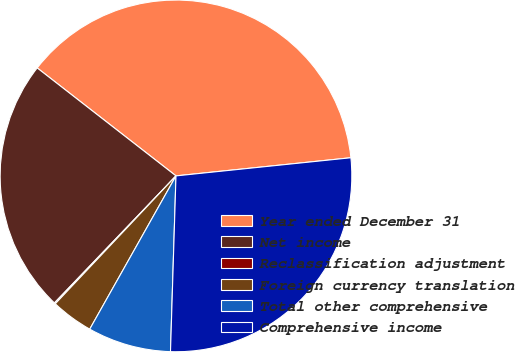<chart> <loc_0><loc_0><loc_500><loc_500><pie_chart><fcel>Year ended December 31<fcel>Net income<fcel>Reclassification adjustment<fcel>Foreign currency translation<fcel>Total other comprehensive<fcel>Comprehensive income<nl><fcel>37.83%<fcel>23.37%<fcel>0.11%<fcel>3.88%<fcel>7.66%<fcel>27.14%<nl></chart> 